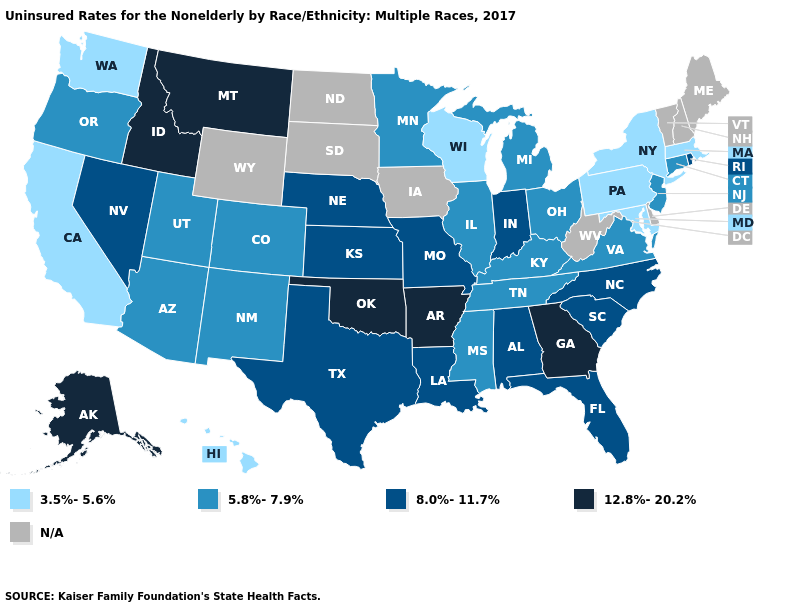What is the highest value in the South ?
Quick response, please. 12.8%-20.2%. What is the highest value in the West ?
Write a very short answer. 12.8%-20.2%. Name the states that have a value in the range 8.0%-11.7%?
Concise answer only. Alabama, Florida, Indiana, Kansas, Louisiana, Missouri, Nebraska, Nevada, North Carolina, Rhode Island, South Carolina, Texas. Among the states that border Vermont , which have the highest value?
Keep it brief. Massachusetts, New York. What is the value of Ohio?
Quick response, please. 5.8%-7.9%. What is the lowest value in the South?
Keep it brief. 3.5%-5.6%. What is the value of New Mexico?
Quick response, please. 5.8%-7.9%. Does Georgia have the highest value in the USA?
Quick response, please. Yes. What is the value of New Hampshire?
Give a very brief answer. N/A. Which states have the highest value in the USA?
Short answer required. Alaska, Arkansas, Georgia, Idaho, Montana, Oklahoma. Does the first symbol in the legend represent the smallest category?
Be succinct. Yes. Name the states that have a value in the range N/A?
Answer briefly. Delaware, Iowa, Maine, New Hampshire, North Dakota, South Dakota, Vermont, West Virginia, Wyoming. Which states have the highest value in the USA?
Be succinct. Alaska, Arkansas, Georgia, Idaho, Montana, Oklahoma. Among the states that border Missouri , does Oklahoma have the highest value?
Concise answer only. Yes. What is the value of Texas?
Be succinct. 8.0%-11.7%. 